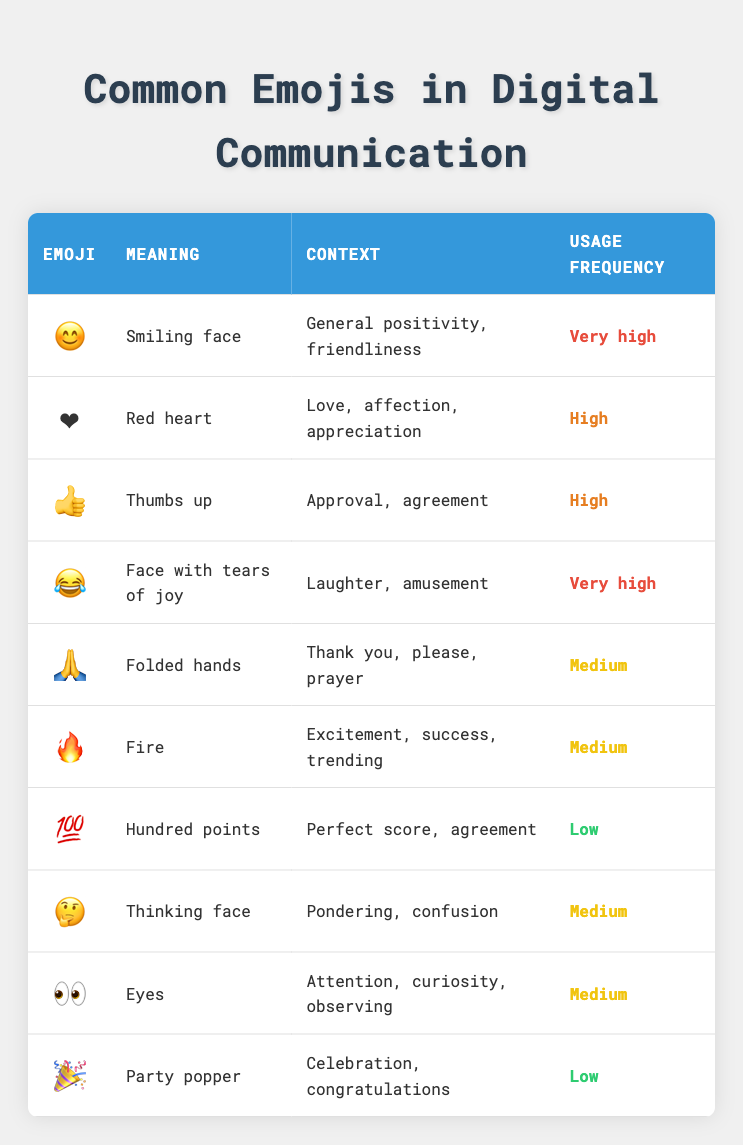What is the meaning of the emoji 😊? The emoji 😊 represents a "Smiling face," which indicates general positivity and friendliness. This can be found in the second column of the corresponding row for the emoji.
Answer: Smiling face Which emoji signifies love or affection? The red heart emoji ❤️ signifies love, affection, and appreciation, as indicated in the second column of the relevant row.
Answer: ❤️ How many emojis have a usage frequency rated as "Very high"? There are 2 emojis, 😊 and 😂, that are rated "Very high." This is determined by counting the instances in the last column where "Very high" appears.
Answer: 2 Is the emoji 🔥 used to express confusion? No, the emoji 🔥 is used to express excitement, success, or trending themes, as stated in the context column. Confusion is represented by the thinking face emoji 🤔 instead.
Answer: No What is the average usage frequency of emojis that indicate celebration or congratulations? The only emoji that indicates celebration or congratulations is 🎉, which has a usage frequency of "Low." As such, the average frequency here is low (since we only have one value).
Answer: Low Which emoji has the highest usage frequency related to laughter? The emoji 😂, "Face with tears of joy," has the highest usage frequency related to laughter, categorized as "Very high." This is confirmed by reviewing the relevant context and frequency columns.
Answer: 😂 Are there more emojis conveying positive sentiments than negative ones? Yes, by analyzing the table, the emojis 😊, ❤️, and 😂 convey positive sentiments, while 🤔 sometimes conveys a neutral to negative sentiment. Thus, there are more emojis indicating positivity.
Answer: Yes What emoji represents the concept of "observing" and what is its usage frequency? The emoji 👀 represents observing and has a usage frequency of "Medium." This can be verified by looking at the context and frequency columns in the same row.
Answer: 👀, Medium What are the meanings of the two emojis with the lowest usage frequency? The emojis 💯 (Hundred points) and 🎉 (Party popper) have the lowest usage frequency. The meanings are "Perfect score, agreement" for 💯 and "Celebration, congratulations" for 🎉. This is determined by analyzing the last column for the "Low" frequency classification.
Answer: 💯: Perfect score, agreement; 🎉: Celebration, congratulations 